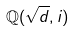<formula> <loc_0><loc_0><loc_500><loc_500>\mathbb { Q } ( \sqrt { d } , i )</formula> 